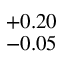<formula> <loc_0><loc_0><loc_500><loc_500>^ { + 0 . 2 0 } _ { - 0 . 0 5 }</formula> 